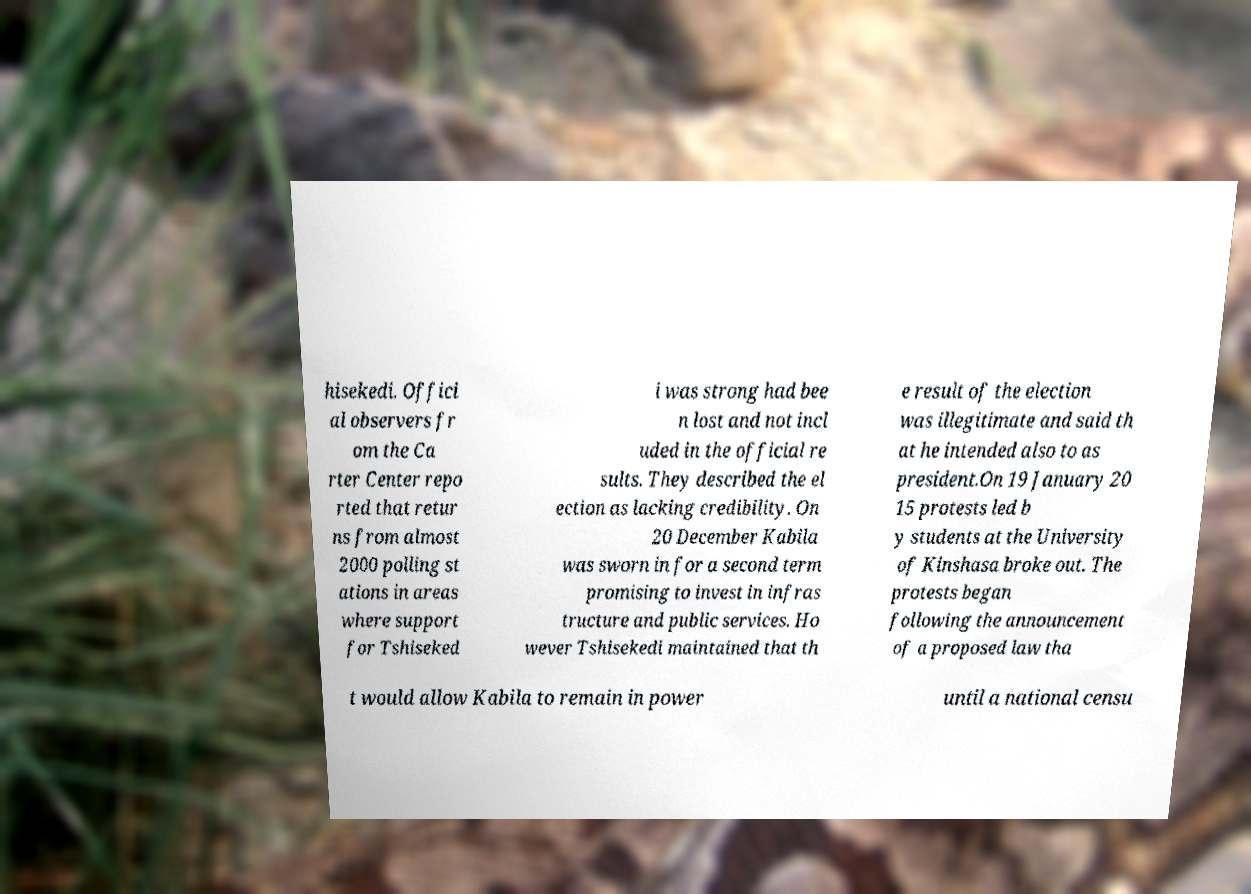What messages or text are displayed in this image? I need them in a readable, typed format. hisekedi. Offici al observers fr om the Ca rter Center repo rted that retur ns from almost 2000 polling st ations in areas where support for Tshiseked i was strong had bee n lost and not incl uded in the official re sults. They described the el ection as lacking credibility. On 20 December Kabila was sworn in for a second term promising to invest in infras tructure and public services. Ho wever Tshisekedi maintained that th e result of the election was illegitimate and said th at he intended also to as president.On 19 January 20 15 protests led b y students at the University of Kinshasa broke out. The protests began following the announcement of a proposed law tha t would allow Kabila to remain in power until a national censu 